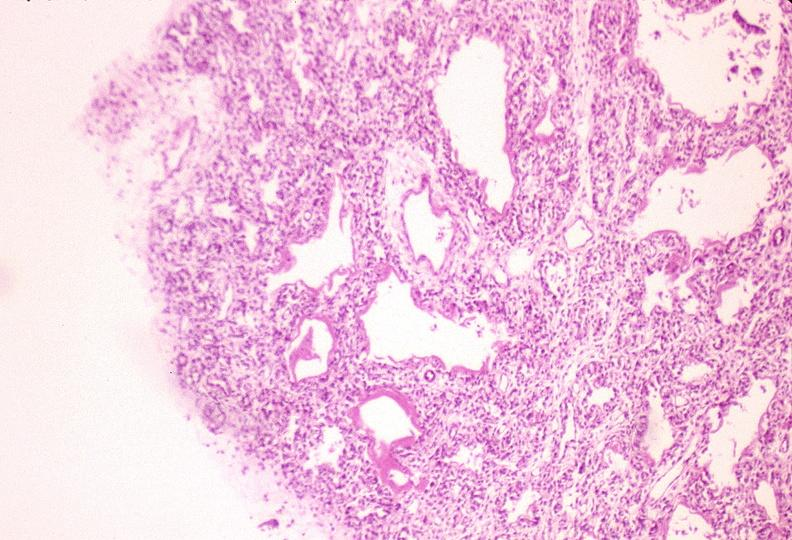does this image show lungs, hyaline membrane disease?
Answer the question using a single word or phrase. Yes 